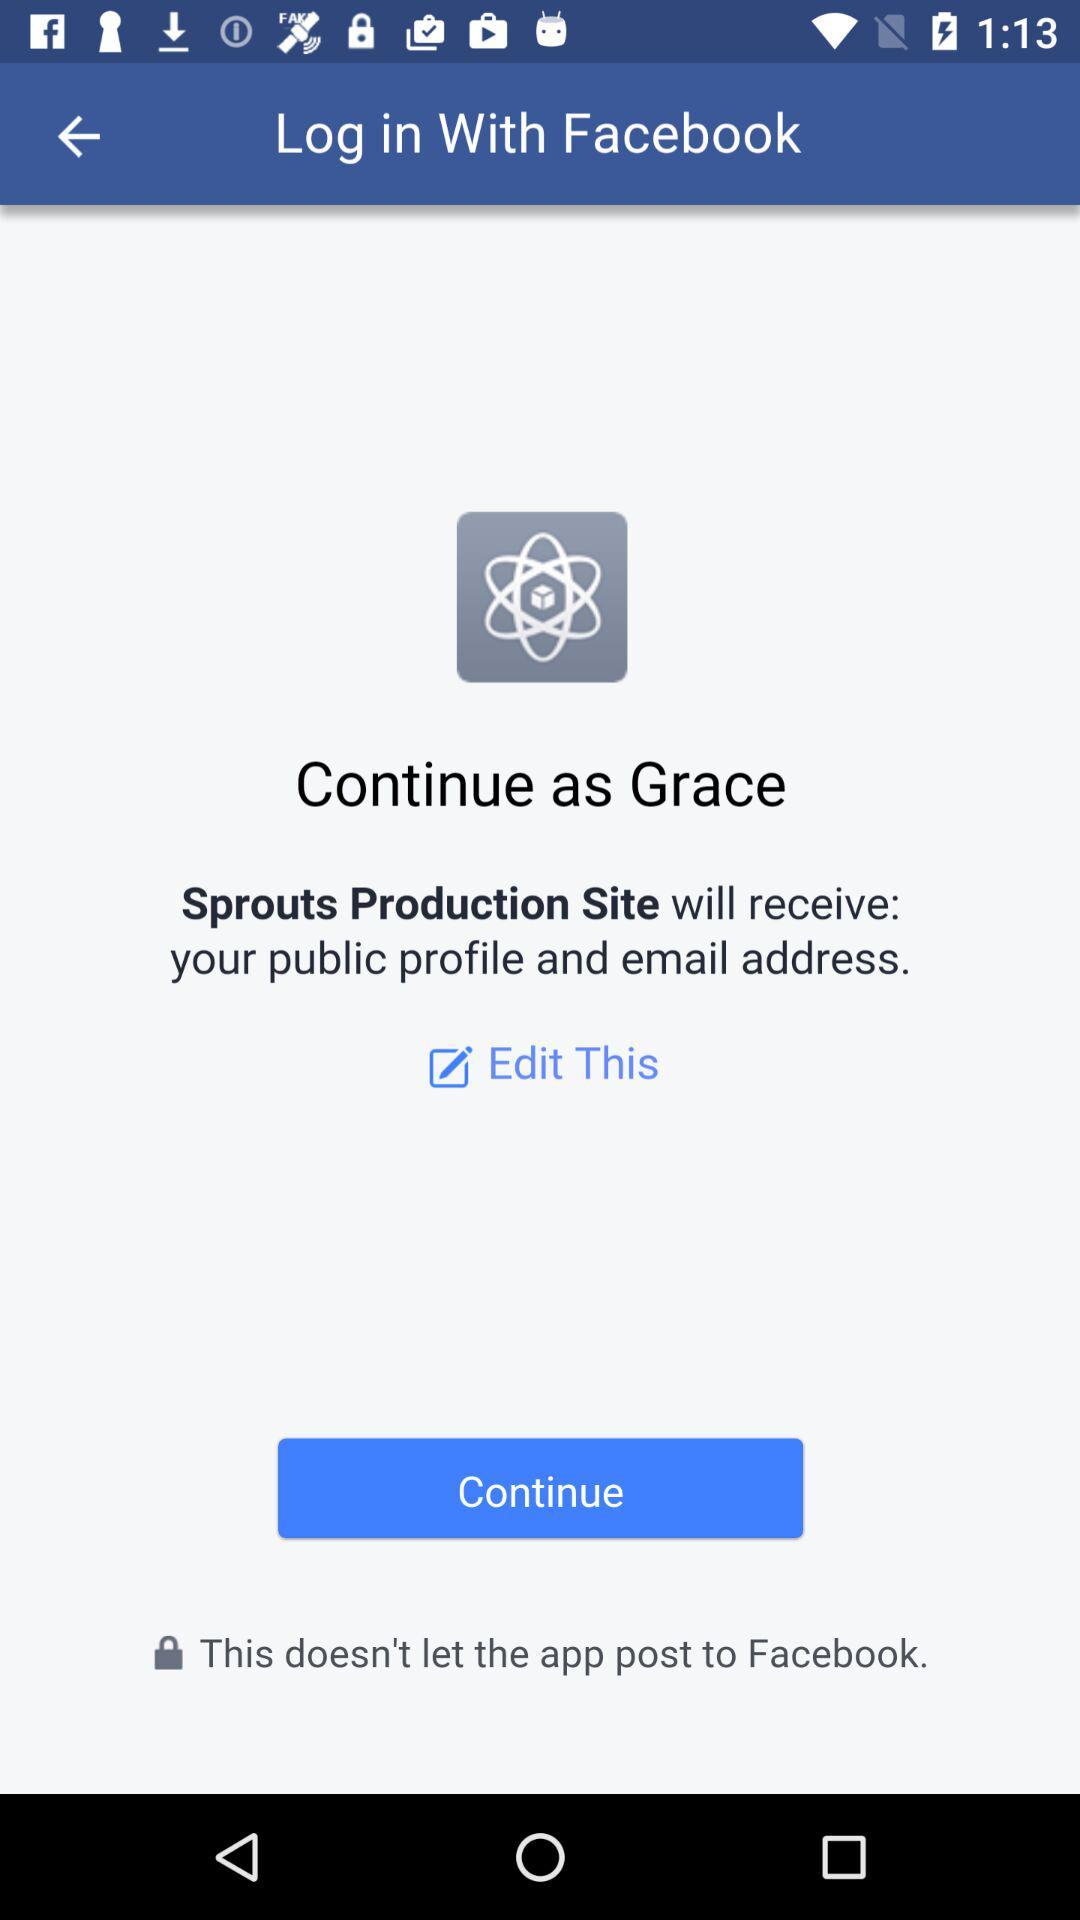What is the login name? The login name is Grace. 